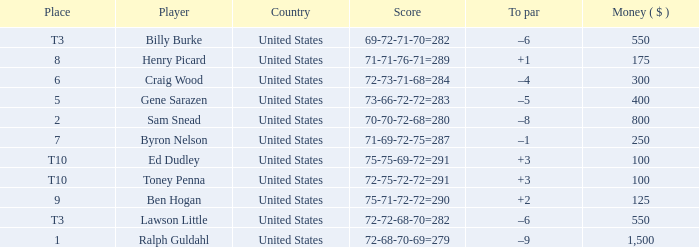Which to par has a prize less than $800? –8. 